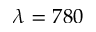<formula> <loc_0><loc_0><loc_500><loc_500>\lambda = 7 8 0</formula> 